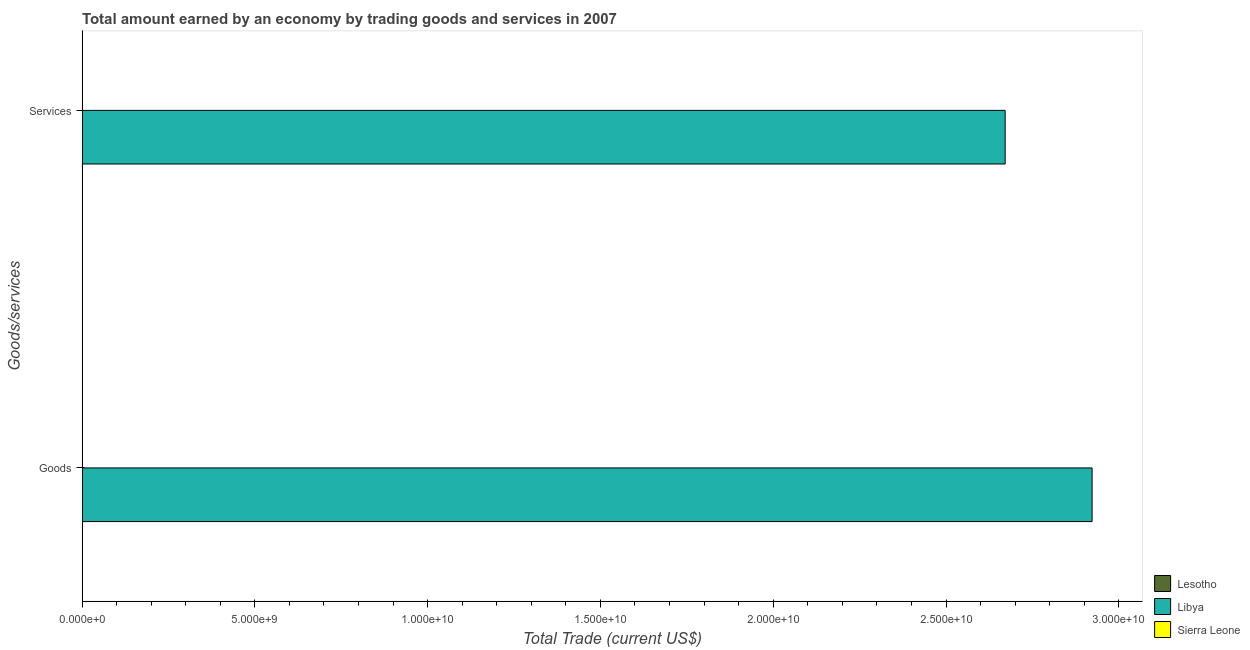How many different coloured bars are there?
Offer a very short reply. 1. Are the number of bars on each tick of the Y-axis equal?
Offer a terse response. Yes. How many bars are there on the 1st tick from the top?
Ensure brevity in your answer.  1. What is the label of the 1st group of bars from the top?
Make the answer very short. Services. What is the amount earned by trading goods in Lesotho?
Offer a very short reply. 0. Across all countries, what is the maximum amount earned by trading goods?
Your response must be concise. 2.92e+1. In which country was the amount earned by trading services maximum?
Your response must be concise. Libya. What is the total amount earned by trading services in the graph?
Ensure brevity in your answer.  2.67e+1. What is the difference between the amount earned by trading services in Sierra Leone and the amount earned by trading goods in Libya?
Keep it short and to the point. -2.92e+1. What is the average amount earned by trading goods per country?
Offer a very short reply. 9.74e+09. What is the difference between the amount earned by trading services and amount earned by trading goods in Libya?
Ensure brevity in your answer.  -2.52e+09. In how many countries, is the amount earned by trading goods greater than 11000000000 US$?
Ensure brevity in your answer.  1. In how many countries, is the amount earned by trading services greater than the average amount earned by trading services taken over all countries?
Your answer should be compact. 1. Are all the bars in the graph horizontal?
Your answer should be compact. Yes. Are the values on the major ticks of X-axis written in scientific E-notation?
Provide a short and direct response. Yes. Does the graph contain any zero values?
Offer a very short reply. Yes. Does the graph contain grids?
Offer a very short reply. No. Where does the legend appear in the graph?
Offer a very short reply. Bottom right. How many legend labels are there?
Offer a very short reply. 3. How are the legend labels stacked?
Your response must be concise. Vertical. What is the title of the graph?
Your answer should be very brief. Total amount earned by an economy by trading goods and services in 2007. Does "Kenya" appear as one of the legend labels in the graph?
Make the answer very short. No. What is the label or title of the X-axis?
Keep it short and to the point. Total Trade (current US$). What is the label or title of the Y-axis?
Offer a very short reply. Goods/services. What is the Total Trade (current US$) of Lesotho in Goods?
Your answer should be very brief. 0. What is the Total Trade (current US$) in Libya in Goods?
Your response must be concise. 2.92e+1. What is the Total Trade (current US$) of Lesotho in Services?
Make the answer very short. 0. What is the Total Trade (current US$) in Libya in Services?
Ensure brevity in your answer.  2.67e+1. What is the Total Trade (current US$) in Sierra Leone in Services?
Make the answer very short. 0. Across all Goods/services, what is the maximum Total Trade (current US$) in Libya?
Provide a succinct answer. 2.92e+1. Across all Goods/services, what is the minimum Total Trade (current US$) of Libya?
Your answer should be very brief. 2.67e+1. What is the total Total Trade (current US$) of Libya in the graph?
Give a very brief answer. 5.59e+1. What is the difference between the Total Trade (current US$) of Libya in Goods and that in Services?
Provide a succinct answer. 2.52e+09. What is the average Total Trade (current US$) of Libya per Goods/services?
Keep it short and to the point. 2.80e+1. What is the average Total Trade (current US$) in Sierra Leone per Goods/services?
Your answer should be very brief. 0. What is the ratio of the Total Trade (current US$) of Libya in Goods to that in Services?
Your answer should be compact. 1.09. What is the difference between the highest and the second highest Total Trade (current US$) of Libya?
Give a very brief answer. 2.52e+09. What is the difference between the highest and the lowest Total Trade (current US$) of Libya?
Ensure brevity in your answer.  2.52e+09. 